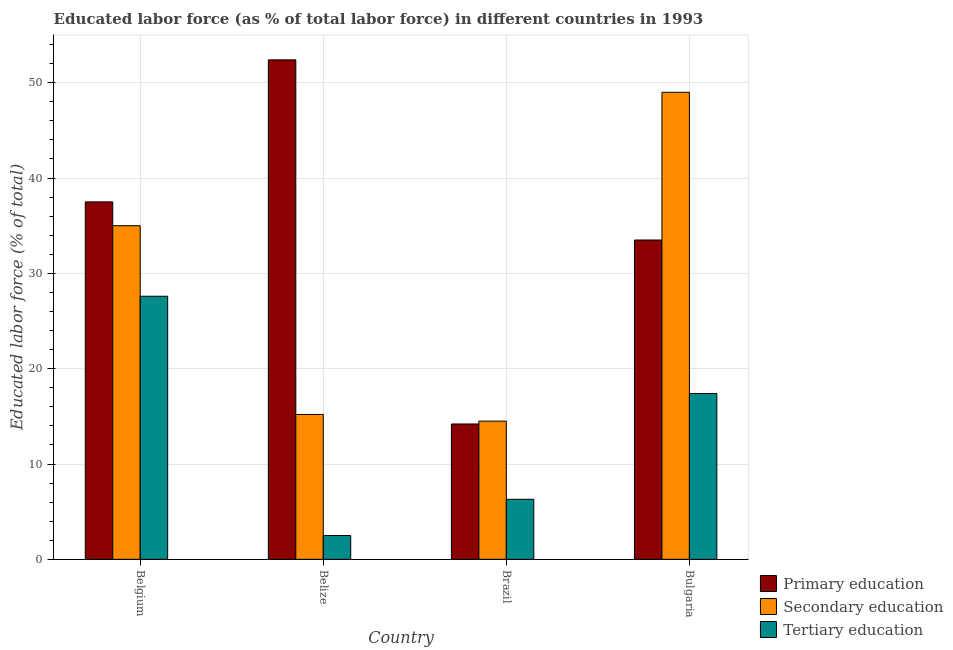How many groups of bars are there?
Offer a terse response. 4. How many bars are there on the 1st tick from the right?
Ensure brevity in your answer.  3. What is the label of the 4th group of bars from the left?
Make the answer very short. Bulgaria. Across all countries, what is the maximum percentage of labor force who received primary education?
Make the answer very short. 52.4. In which country was the percentage of labor force who received primary education maximum?
Ensure brevity in your answer.  Belize. In which country was the percentage of labor force who received tertiary education minimum?
Ensure brevity in your answer.  Belize. What is the total percentage of labor force who received tertiary education in the graph?
Give a very brief answer. 53.8. What is the difference between the percentage of labor force who received primary education in Belize and that in Bulgaria?
Provide a short and direct response. 18.9. What is the difference between the percentage of labor force who received tertiary education in Brazil and the percentage of labor force who received secondary education in Belgium?
Your response must be concise. -28.7. What is the average percentage of labor force who received tertiary education per country?
Your response must be concise. 13.45. What is the difference between the percentage of labor force who received secondary education and percentage of labor force who received tertiary education in Belgium?
Your answer should be very brief. 7.4. What is the ratio of the percentage of labor force who received primary education in Brazil to that in Bulgaria?
Your response must be concise. 0.42. What is the difference between the highest and the second highest percentage of labor force who received tertiary education?
Provide a succinct answer. 10.2. What is the difference between the highest and the lowest percentage of labor force who received tertiary education?
Offer a very short reply. 25.1. Is the sum of the percentage of labor force who received tertiary education in Belgium and Belize greater than the maximum percentage of labor force who received secondary education across all countries?
Give a very brief answer. No. What does the 3rd bar from the right in Bulgaria represents?
Your response must be concise. Primary education. Are all the bars in the graph horizontal?
Your answer should be compact. No. How many countries are there in the graph?
Provide a short and direct response. 4. What is the difference between two consecutive major ticks on the Y-axis?
Offer a terse response. 10. Does the graph contain grids?
Give a very brief answer. Yes. Where does the legend appear in the graph?
Your response must be concise. Bottom right. How many legend labels are there?
Keep it short and to the point. 3. How are the legend labels stacked?
Offer a very short reply. Vertical. What is the title of the graph?
Keep it short and to the point. Educated labor force (as % of total labor force) in different countries in 1993. Does "Neonatal" appear as one of the legend labels in the graph?
Your answer should be very brief. No. What is the label or title of the X-axis?
Offer a very short reply. Country. What is the label or title of the Y-axis?
Keep it short and to the point. Educated labor force (% of total). What is the Educated labor force (% of total) of Primary education in Belgium?
Provide a succinct answer. 37.5. What is the Educated labor force (% of total) of Tertiary education in Belgium?
Give a very brief answer. 27.6. What is the Educated labor force (% of total) in Primary education in Belize?
Your answer should be very brief. 52.4. What is the Educated labor force (% of total) of Secondary education in Belize?
Make the answer very short. 15.2. What is the Educated labor force (% of total) of Primary education in Brazil?
Keep it short and to the point. 14.2. What is the Educated labor force (% of total) in Secondary education in Brazil?
Your answer should be very brief. 14.5. What is the Educated labor force (% of total) in Tertiary education in Brazil?
Your answer should be compact. 6.3. What is the Educated labor force (% of total) of Primary education in Bulgaria?
Keep it short and to the point. 33.5. What is the Educated labor force (% of total) in Tertiary education in Bulgaria?
Keep it short and to the point. 17.4. Across all countries, what is the maximum Educated labor force (% of total) in Primary education?
Provide a succinct answer. 52.4. Across all countries, what is the maximum Educated labor force (% of total) in Tertiary education?
Your response must be concise. 27.6. Across all countries, what is the minimum Educated labor force (% of total) of Primary education?
Provide a succinct answer. 14.2. Across all countries, what is the minimum Educated labor force (% of total) in Secondary education?
Provide a short and direct response. 14.5. Across all countries, what is the minimum Educated labor force (% of total) of Tertiary education?
Provide a short and direct response. 2.5. What is the total Educated labor force (% of total) of Primary education in the graph?
Make the answer very short. 137.6. What is the total Educated labor force (% of total) of Secondary education in the graph?
Make the answer very short. 113.7. What is the total Educated labor force (% of total) of Tertiary education in the graph?
Provide a succinct answer. 53.8. What is the difference between the Educated labor force (% of total) in Primary education in Belgium and that in Belize?
Make the answer very short. -14.9. What is the difference between the Educated labor force (% of total) of Secondary education in Belgium and that in Belize?
Your answer should be compact. 19.8. What is the difference between the Educated labor force (% of total) in Tertiary education in Belgium and that in Belize?
Your answer should be very brief. 25.1. What is the difference between the Educated labor force (% of total) of Primary education in Belgium and that in Brazil?
Offer a very short reply. 23.3. What is the difference between the Educated labor force (% of total) of Tertiary education in Belgium and that in Brazil?
Provide a short and direct response. 21.3. What is the difference between the Educated labor force (% of total) in Secondary education in Belgium and that in Bulgaria?
Provide a succinct answer. -14. What is the difference between the Educated labor force (% of total) of Primary education in Belize and that in Brazil?
Make the answer very short. 38.2. What is the difference between the Educated labor force (% of total) in Secondary education in Belize and that in Brazil?
Give a very brief answer. 0.7. What is the difference between the Educated labor force (% of total) in Tertiary education in Belize and that in Brazil?
Ensure brevity in your answer.  -3.8. What is the difference between the Educated labor force (% of total) of Primary education in Belize and that in Bulgaria?
Your answer should be very brief. 18.9. What is the difference between the Educated labor force (% of total) of Secondary education in Belize and that in Bulgaria?
Ensure brevity in your answer.  -33.8. What is the difference between the Educated labor force (% of total) in Tertiary education in Belize and that in Bulgaria?
Provide a succinct answer. -14.9. What is the difference between the Educated labor force (% of total) of Primary education in Brazil and that in Bulgaria?
Your answer should be very brief. -19.3. What is the difference between the Educated labor force (% of total) of Secondary education in Brazil and that in Bulgaria?
Make the answer very short. -34.5. What is the difference between the Educated labor force (% of total) of Primary education in Belgium and the Educated labor force (% of total) of Secondary education in Belize?
Provide a short and direct response. 22.3. What is the difference between the Educated labor force (% of total) in Secondary education in Belgium and the Educated labor force (% of total) in Tertiary education in Belize?
Provide a short and direct response. 32.5. What is the difference between the Educated labor force (% of total) in Primary education in Belgium and the Educated labor force (% of total) in Tertiary education in Brazil?
Ensure brevity in your answer.  31.2. What is the difference between the Educated labor force (% of total) of Secondary education in Belgium and the Educated labor force (% of total) of Tertiary education in Brazil?
Offer a terse response. 28.7. What is the difference between the Educated labor force (% of total) in Primary education in Belgium and the Educated labor force (% of total) in Secondary education in Bulgaria?
Offer a terse response. -11.5. What is the difference between the Educated labor force (% of total) in Primary education in Belgium and the Educated labor force (% of total) in Tertiary education in Bulgaria?
Offer a terse response. 20.1. What is the difference between the Educated labor force (% of total) of Primary education in Belize and the Educated labor force (% of total) of Secondary education in Brazil?
Your answer should be very brief. 37.9. What is the difference between the Educated labor force (% of total) of Primary education in Belize and the Educated labor force (% of total) of Tertiary education in Brazil?
Your response must be concise. 46.1. What is the difference between the Educated labor force (% of total) in Primary education in Belize and the Educated labor force (% of total) in Secondary education in Bulgaria?
Keep it short and to the point. 3.4. What is the difference between the Educated labor force (% of total) of Primary education in Brazil and the Educated labor force (% of total) of Secondary education in Bulgaria?
Provide a short and direct response. -34.8. What is the average Educated labor force (% of total) in Primary education per country?
Keep it short and to the point. 34.4. What is the average Educated labor force (% of total) of Secondary education per country?
Make the answer very short. 28.43. What is the average Educated labor force (% of total) of Tertiary education per country?
Your answer should be compact. 13.45. What is the difference between the Educated labor force (% of total) of Secondary education and Educated labor force (% of total) of Tertiary education in Belgium?
Offer a terse response. 7.4. What is the difference between the Educated labor force (% of total) of Primary education and Educated labor force (% of total) of Secondary education in Belize?
Keep it short and to the point. 37.2. What is the difference between the Educated labor force (% of total) in Primary education and Educated labor force (% of total) in Tertiary education in Belize?
Offer a terse response. 49.9. What is the difference between the Educated labor force (% of total) of Primary education and Educated labor force (% of total) of Tertiary education in Brazil?
Your answer should be very brief. 7.9. What is the difference between the Educated labor force (% of total) of Primary education and Educated labor force (% of total) of Secondary education in Bulgaria?
Provide a succinct answer. -15.5. What is the difference between the Educated labor force (% of total) of Secondary education and Educated labor force (% of total) of Tertiary education in Bulgaria?
Offer a very short reply. 31.6. What is the ratio of the Educated labor force (% of total) of Primary education in Belgium to that in Belize?
Offer a very short reply. 0.72. What is the ratio of the Educated labor force (% of total) of Secondary education in Belgium to that in Belize?
Your answer should be very brief. 2.3. What is the ratio of the Educated labor force (% of total) of Tertiary education in Belgium to that in Belize?
Offer a terse response. 11.04. What is the ratio of the Educated labor force (% of total) in Primary education in Belgium to that in Brazil?
Offer a terse response. 2.64. What is the ratio of the Educated labor force (% of total) in Secondary education in Belgium to that in Brazil?
Your answer should be compact. 2.41. What is the ratio of the Educated labor force (% of total) of Tertiary education in Belgium to that in Brazil?
Ensure brevity in your answer.  4.38. What is the ratio of the Educated labor force (% of total) of Primary education in Belgium to that in Bulgaria?
Offer a terse response. 1.12. What is the ratio of the Educated labor force (% of total) of Tertiary education in Belgium to that in Bulgaria?
Make the answer very short. 1.59. What is the ratio of the Educated labor force (% of total) in Primary education in Belize to that in Brazil?
Your answer should be compact. 3.69. What is the ratio of the Educated labor force (% of total) of Secondary education in Belize to that in Brazil?
Make the answer very short. 1.05. What is the ratio of the Educated labor force (% of total) in Tertiary education in Belize to that in Brazil?
Offer a terse response. 0.4. What is the ratio of the Educated labor force (% of total) of Primary education in Belize to that in Bulgaria?
Keep it short and to the point. 1.56. What is the ratio of the Educated labor force (% of total) in Secondary education in Belize to that in Bulgaria?
Provide a succinct answer. 0.31. What is the ratio of the Educated labor force (% of total) of Tertiary education in Belize to that in Bulgaria?
Provide a short and direct response. 0.14. What is the ratio of the Educated labor force (% of total) in Primary education in Brazil to that in Bulgaria?
Offer a very short reply. 0.42. What is the ratio of the Educated labor force (% of total) of Secondary education in Brazil to that in Bulgaria?
Give a very brief answer. 0.3. What is the ratio of the Educated labor force (% of total) of Tertiary education in Brazil to that in Bulgaria?
Provide a short and direct response. 0.36. What is the difference between the highest and the lowest Educated labor force (% of total) in Primary education?
Provide a short and direct response. 38.2. What is the difference between the highest and the lowest Educated labor force (% of total) of Secondary education?
Offer a terse response. 34.5. What is the difference between the highest and the lowest Educated labor force (% of total) of Tertiary education?
Provide a succinct answer. 25.1. 